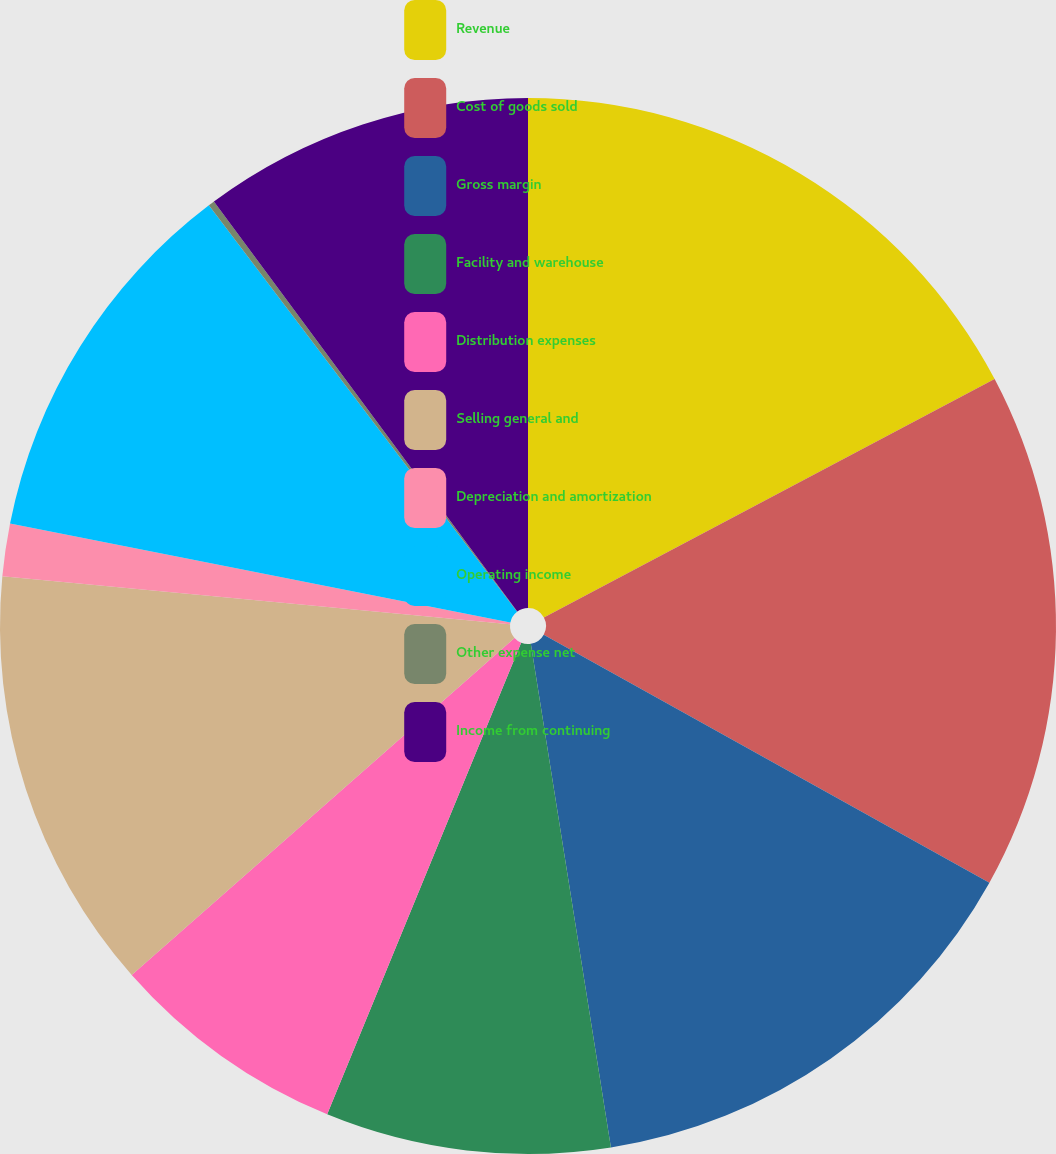<chart> <loc_0><loc_0><loc_500><loc_500><pie_chart><fcel>Revenue<fcel>Cost of goods sold<fcel>Gross margin<fcel>Facility and warehouse<fcel>Distribution expenses<fcel>Selling general and<fcel>Depreciation and amortization<fcel>Operating income<fcel>Other expense net<fcel>Income from continuing<nl><fcel>17.25%<fcel>15.83%<fcel>14.41%<fcel>8.72%<fcel>7.3%<fcel>12.99%<fcel>1.61%<fcel>11.56%<fcel>0.19%<fcel>10.14%<nl></chart> 